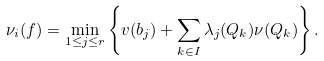<formula> <loc_0><loc_0><loc_500><loc_500>\nu _ { i } ( f ) = \min _ { 1 \leq j \leq r } \left \{ v ( b _ { j } ) + \sum _ { k \in I } \lambda _ { j } ( Q _ { k } ) \nu ( Q _ { k } ) \right \} .</formula> 